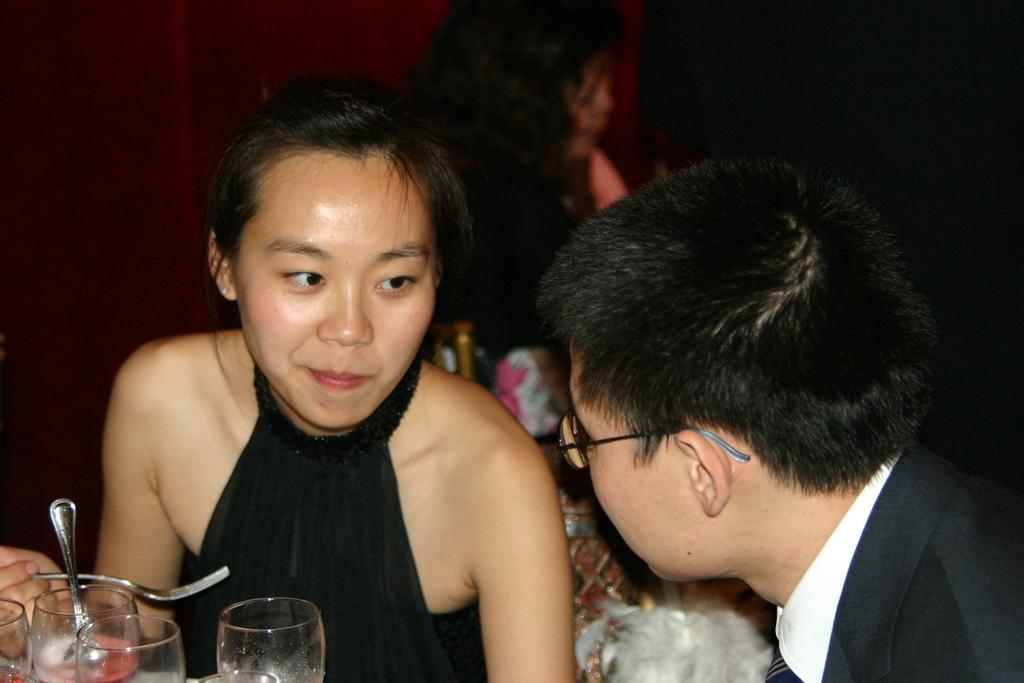How many people are sitting in the image? There are two persons sitting in the image. What objects are in front of the sitting persons? There are glasses in front of the sitting persons. Can you describe the person in the background? There is a person in the background, but no specific details are provided. What type of snail can be seen crawling on the table in the image? There is no snail present in the image; it only features two sitting persons and a person in the background. 